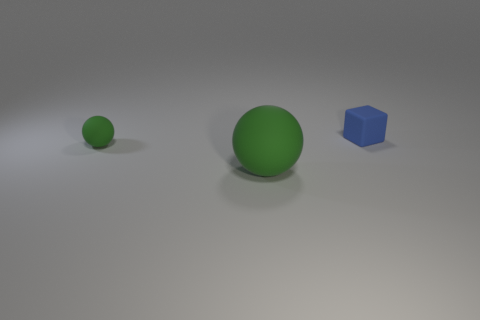Is there a tiny rubber object that has the same color as the large thing?
Make the answer very short. Yes. There is a ball left of the big matte object; is its color the same as the matte sphere on the right side of the small green thing?
Provide a succinct answer. Yes. How many other objects are the same shape as the large green rubber thing?
Give a very brief answer. 1. Are there any cylinders?
Offer a terse response. No. What number of objects are tiny gray cylinders or rubber objects in front of the tiny blue rubber object?
Keep it short and to the point. 2. What number of other objects are there of the same size as the blue object?
Provide a short and direct response. 1. The rubber cube is what color?
Your answer should be compact. Blue. There is a ball right of the small green sphere; what material is it?
Provide a short and direct response. Rubber. Are there the same number of objects that are behind the tiny blue thing and small spheres?
Ensure brevity in your answer.  No. Is the shape of the small green object the same as the large object?
Ensure brevity in your answer.  Yes. 